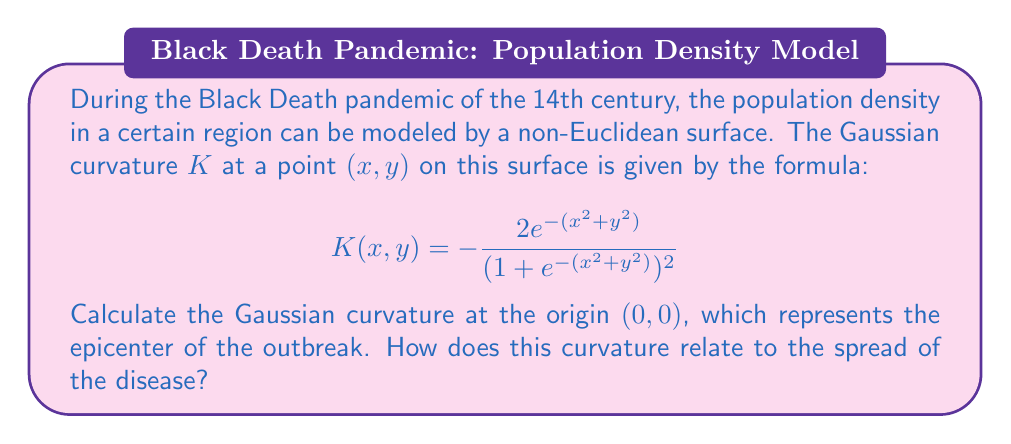Help me with this question. To solve this problem, we need to follow these steps:

1) The formula for the Gaussian curvature is given as:

   $$K(x,y) = -\frac{2e^{-(x^2+y^2)}}{(1+e^{-(x^2+y^2)})^2}$$

2) We need to calculate this at the point $(0,0)$, so we substitute $x=0$ and $y=0$:

   $$K(0,0) = -\frac{2e^{-(0^2+0^2)}}{(1+e^{-(0^2+0^2)})^2}$$

3) Simplify the exponents:

   $$K(0,0) = -\frac{2e^{-0}}{(1+e^{-0})^2}$$

4) Recall that $e^0 = 1$:

   $$K(0,0) = -\frac{2 \cdot 1}{(1+1)^2} = -\frac{2}{4} = -\frac{1}{2}$$

5) Therefore, the Gaussian curvature at the origin is $-\frac{1}{2}$.

6) Interpretation: The negative curvature at the epicenter indicates that the population density decreases rapidly as we move away from the center. This negative curvature creates a "saddle-like" shape, which in the context of an epidemic, suggests that the disease spread quickly from the epicenter to surrounding areas. The magnitude of $\frac{1}{2}$ gives us an idea of how steep this decrease is.
Answer: $K(0,0) = -\frac{1}{2}$ 